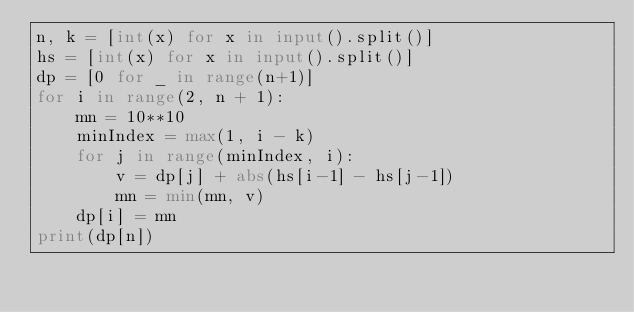Convert code to text. <code><loc_0><loc_0><loc_500><loc_500><_Python_>n, k = [int(x) for x in input().split()]
hs = [int(x) for x in input().split()]
dp = [0 for _ in range(n+1)]
for i in range(2, n + 1):
    mn = 10**10
    minIndex = max(1, i - k)
    for j in range(minIndex, i):
        v = dp[j] + abs(hs[i-1] - hs[j-1])
        mn = min(mn, v)
    dp[i] = mn
print(dp[n])
</code> 